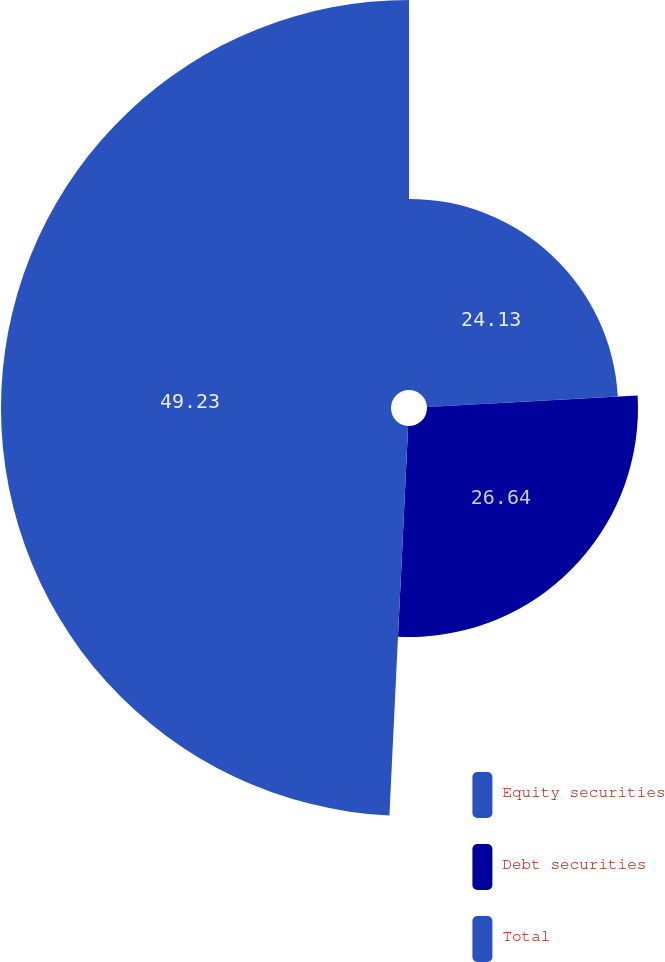Convert chart. <chart><loc_0><loc_0><loc_500><loc_500><pie_chart><fcel>Equity securities<fcel>Debt securities<fcel>Total<nl><fcel>24.13%<fcel>26.64%<fcel>49.24%<nl></chart> 